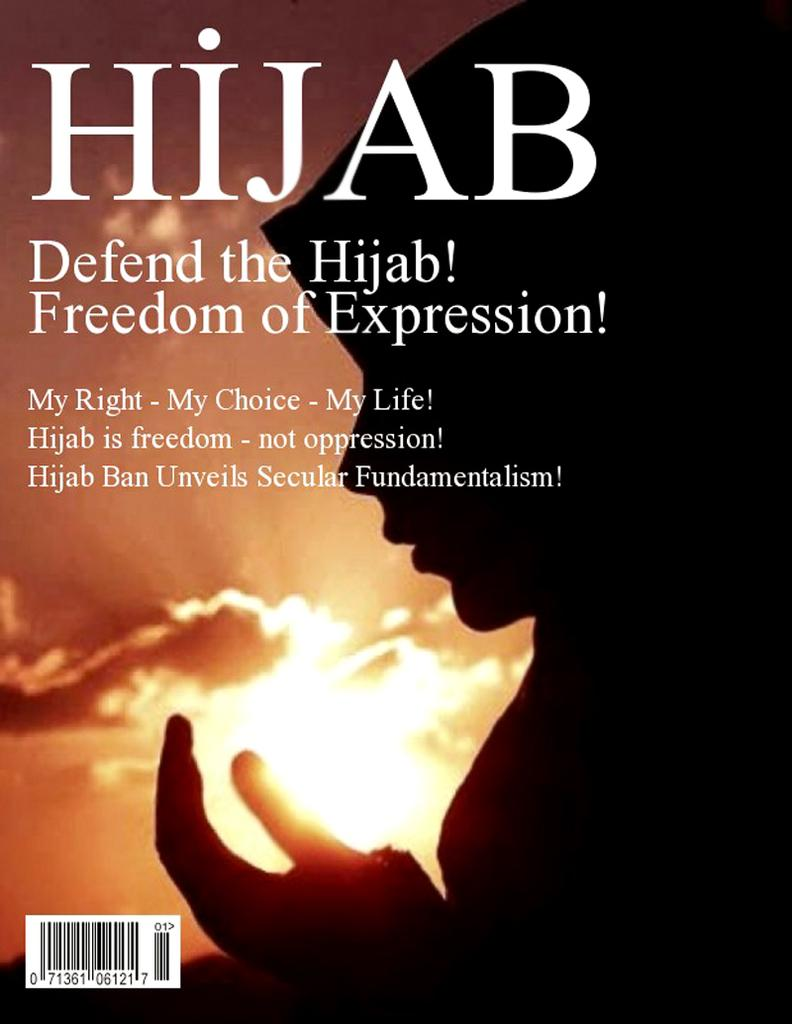<image>
Share a concise interpretation of the image provided. A book titled Hijab shows a woman wearing a Hijab with the words Defend the Hijab! written on the cover 